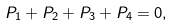<formula> <loc_0><loc_0><loc_500><loc_500>P _ { 1 } + P _ { 2 } + P _ { 3 } + P _ { 4 } = 0 ,</formula> 